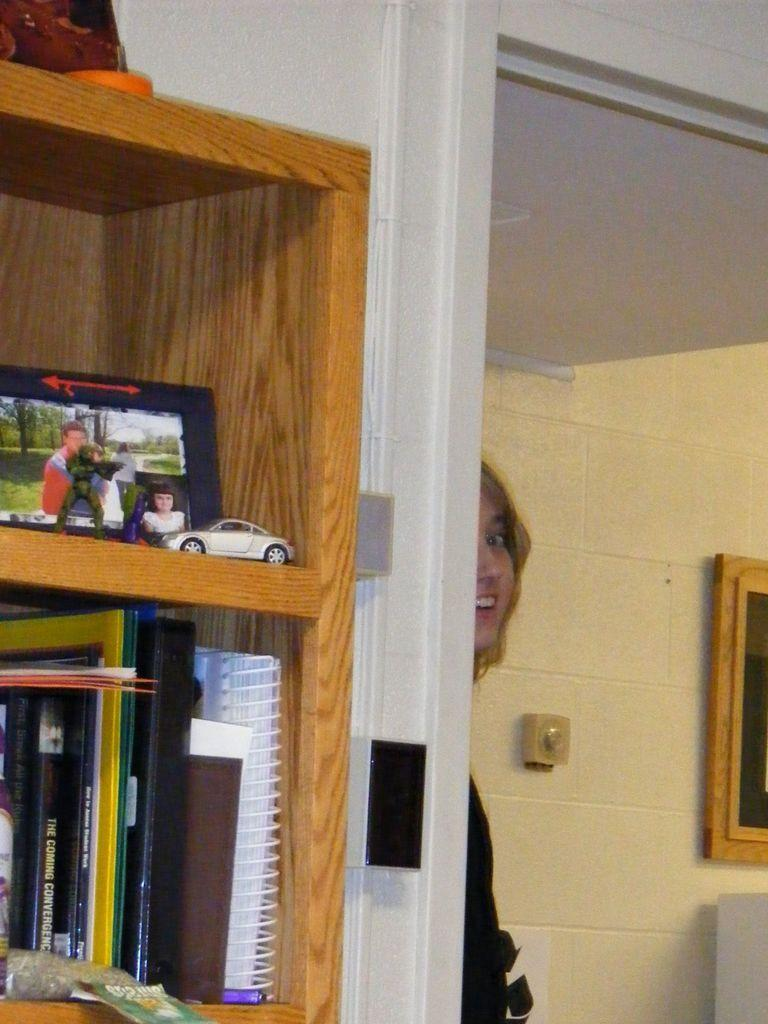Who is present in the image? There is a woman in the image. What is the woman doing in the image? The woman is standing on the floor. What can be seen in the mirror in the image? The woman's reflection is visible in a mirror. What is located behind the woman in the image? There are objects arranged in a cupboard in the image. What type of juice is being squeezed out of the woman's nerves in the image? There is no juice or nerve present in the image; it features a woman standing on the floor with her reflection visible in a mirror and objects arranged in a cupboard. 